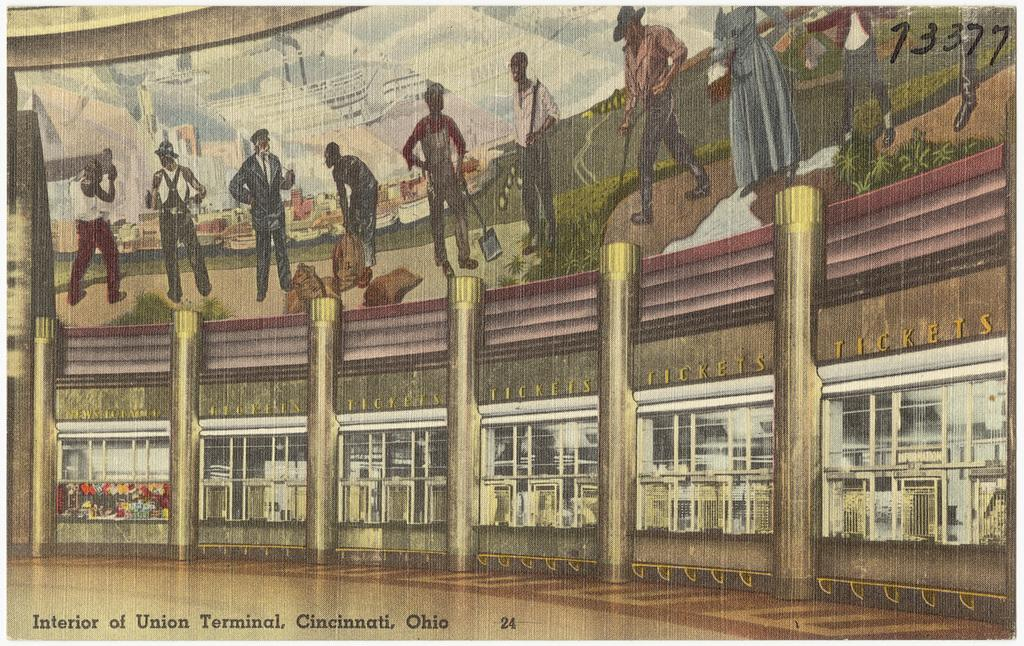What is the main subject of the image? There is a painting in the image. What can be found within the painting? The painting contains pictures and text. Is there any text outside of the painting in the image? Yes, there is text at the bottom of the image. Can you tell me how many snakes are depicted in the painting? There is no mention of snakes in the image or the painting; it contains pictures and text, but no snakes. 